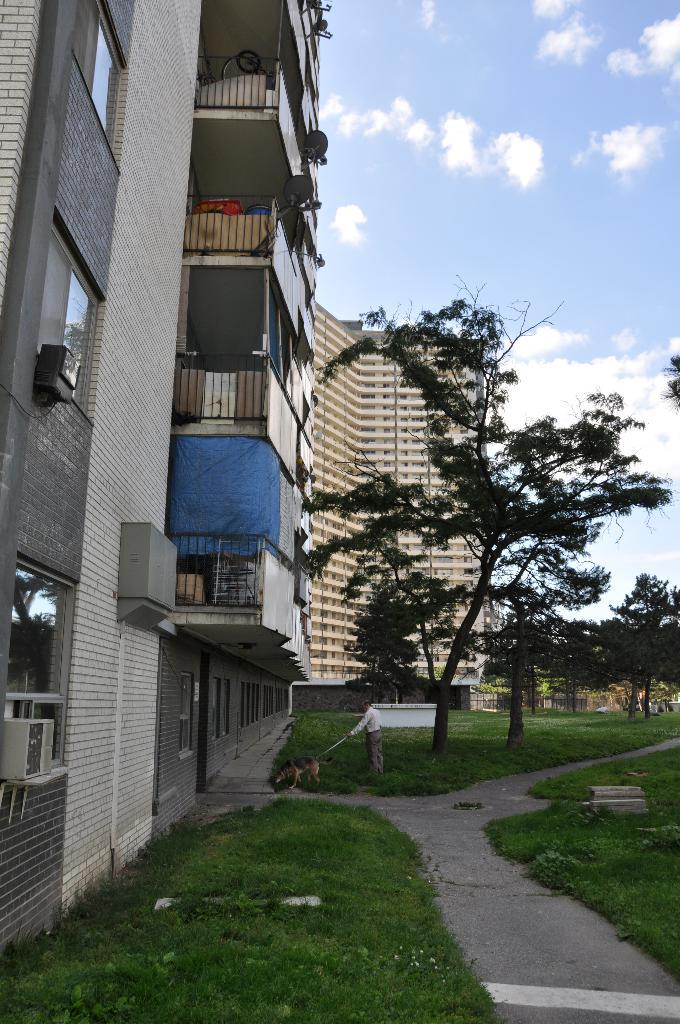What type of terrain is visible in the image? There is grassy land in the image. What other natural elements can be seen in the image? There are trees in the image. Where are the buildings located in the image? The buildings are present on the left side of the image. What is visible in the sky in the image? The sky is visible in the image, and there are clouds in the sky. What type of berry is growing on the trees in the image? There are no berries visible on the trees in the image; only leaves and branches can be seen. What musical instrument is being played in the image? There is no musical instrument or person playing an instrument present in the image. 